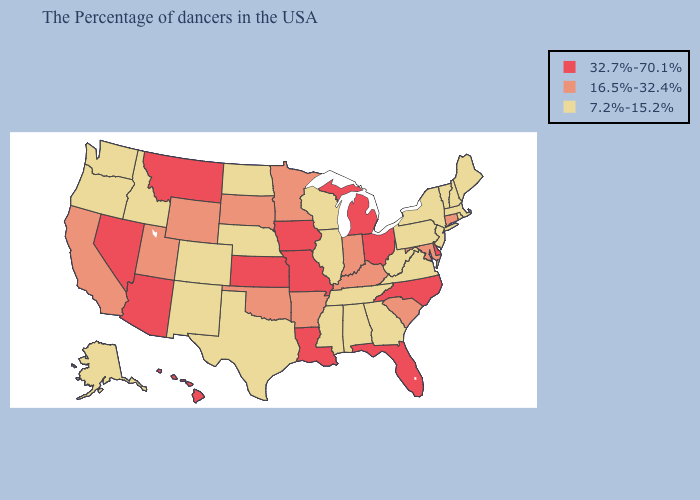Does Iowa have the lowest value in the USA?
Concise answer only. No. What is the value of Hawaii?
Quick response, please. 32.7%-70.1%. What is the highest value in the USA?
Write a very short answer. 32.7%-70.1%. What is the highest value in the USA?
Write a very short answer. 32.7%-70.1%. Among the states that border Colorado , does New Mexico have the lowest value?
Quick response, please. Yes. What is the lowest value in the USA?
Keep it brief. 7.2%-15.2%. Does South Dakota have a higher value than Florida?
Answer briefly. No. Name the states that have a value in the range 7.2%-15.2%?
Concise answer only. Maine, Massachusetts, Rhode Island, New Hampshire, Vermont, New York, New Jersey, Pennsylvania, Virginia, West Virginia, Georgia, Alabama, Tennessee, Wisconsin, Illinois, Mississippi, Nebraska, Texas, North Dakota, Colorado, New Mexico, Idaho, Washington, Oregon, Alaska. Does Louisiana have a higher value than Nevada?
Keep it brief. No. Which states have the highest value in the USA?
Give a very brief answer. Delaware, North Carolina, Ohio, Florida, Michigan, Louisiana, Missouri, Iowa, Kansas, Montana, Arizona, Nevada, Hawaii. Among the states that border Delaware , does Pennsylvania have the lowest value?
Answer briefly. Yes. Among the states that border Ohio , which have the lowest value?
Concise answer only. Pennsylvania, West Virginia. Which states have the highest value in the USA?
Concise answer only. Delaware, North Carolina, Ohio, Florida, Michigan, Louisiana, Missouri, Iowa, Kansas, Montana, Arizona, Nevada, Hawaii. Name the states that have a value in the range 7.2%-15.2%?
Write a very short answer. Maine, Massachusetts, Rhode Island, New Hampshire, Vermont, New York, New Jersey, Pennsylvania, Virginia, West Virginia, Georgia, Alabama, Tennessee, Wisconsin, Illinois, Mississippi, Nebraska, Texas, North Dakota, Colorado, New Mexico, Idaho, Washington, Oregon, Alaska. Name the states that have a value in the range 32.7%-70.1%?
Give a very brief answer. Delaware, North Carolina, Ohio, Florida, Michigan, Louisiana, Missouri, Iowa, Kansas, Montana, Arizona, Nevada, Hawaii. 